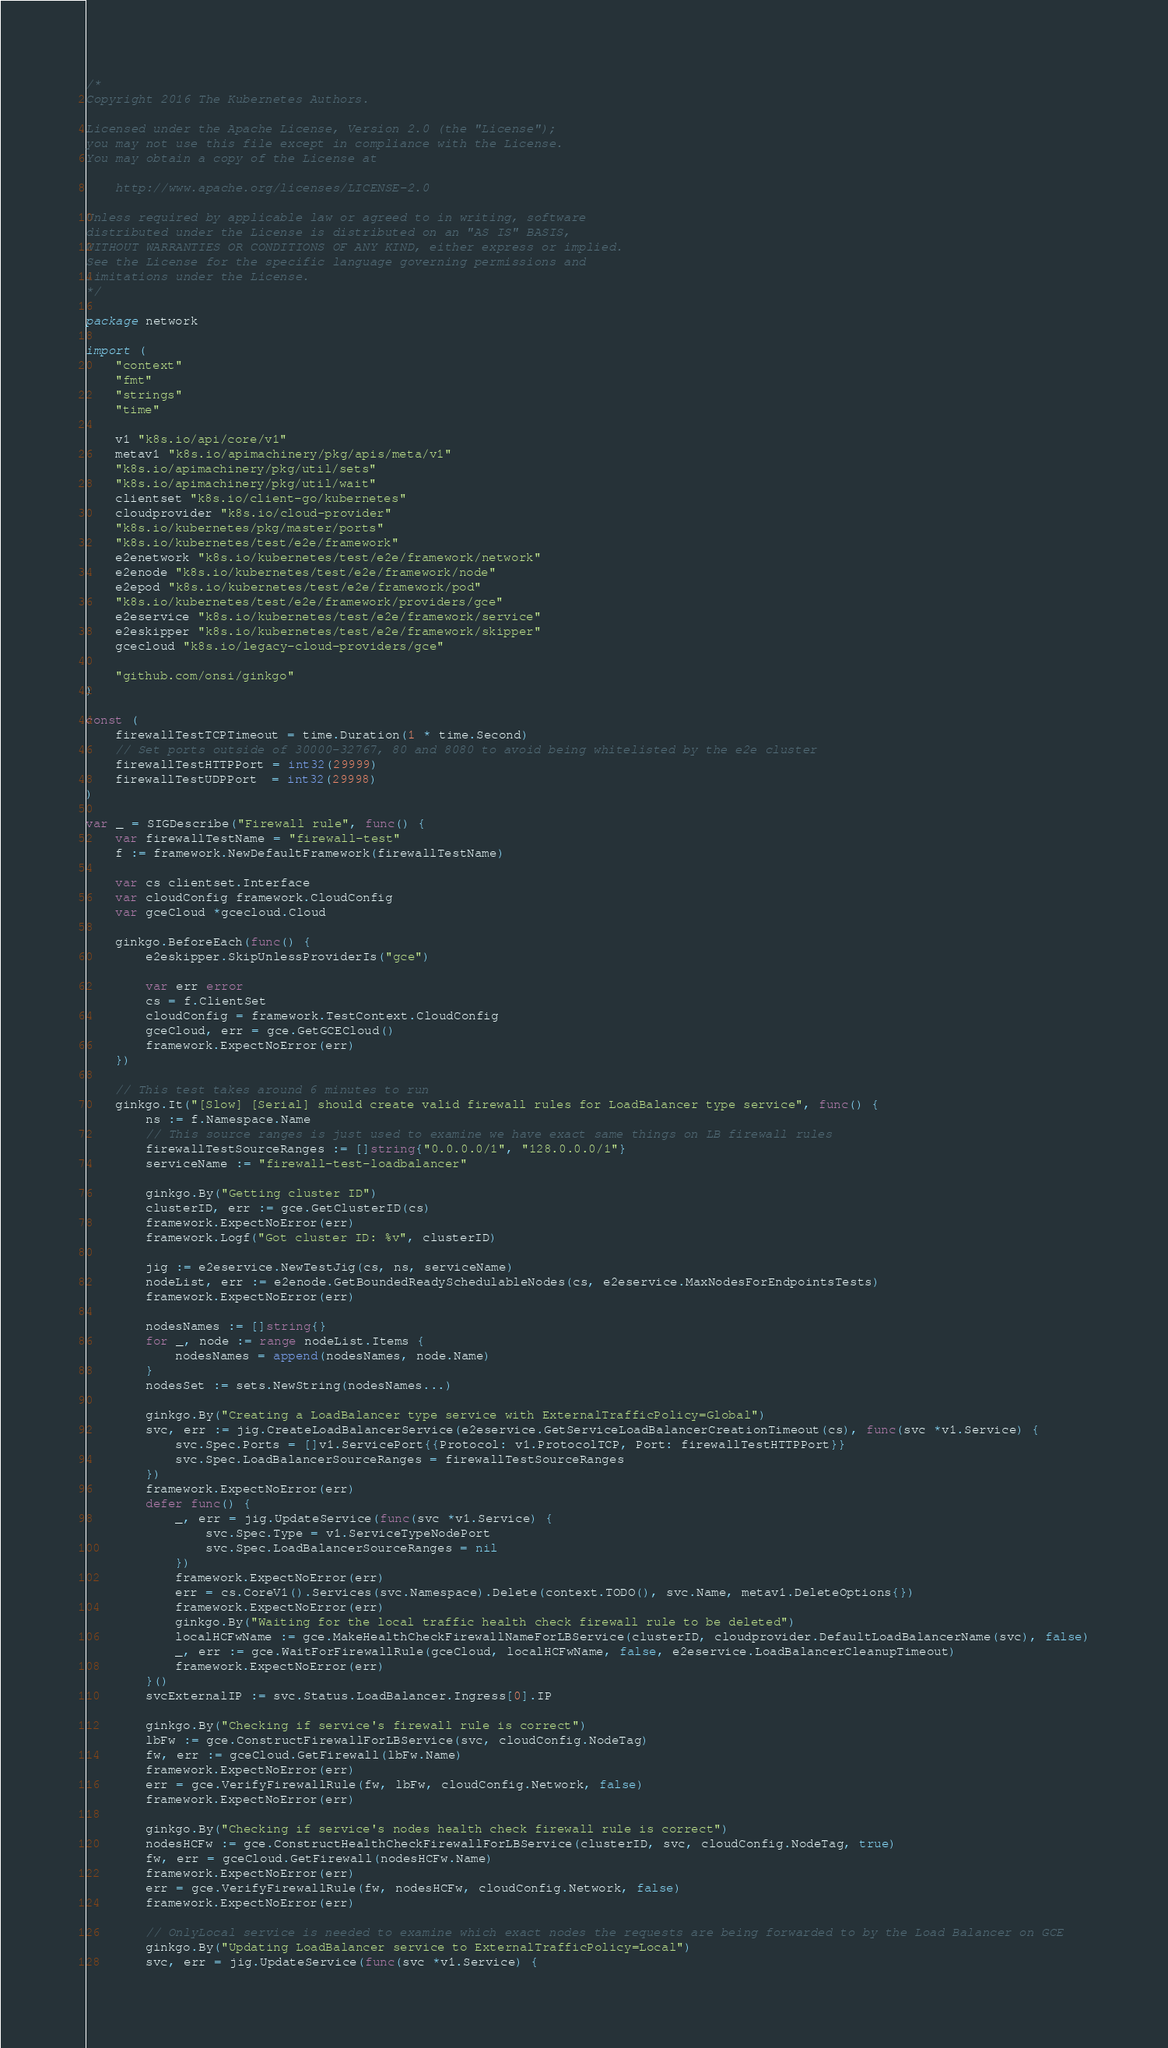Convert code to text. <code><loc_0><loc_0><loc_500><loc_500><_Go_>/*
Copyright 2016 The Kubernetes Authors.

Licensed under the Apache License, Version 2.0 (the "License");
you may not use this file except in compliance with the License.
You may obtain a copy of the License at

    http://www.apache.org/licenses/LICENSE-2.0

Unless required by applicable law or agreed to in writing, software
distributed under the License is distributed on an "AS IS" BASIS,
WITHOUT WARRANTIES OR CONDITIONS OF ANY KIND, either express or implied.
See the License for the specific language governing permissions and
limitations under the License.
*/

package network

import (
	"context"
	"fmt"
	"strings"
	"time"

	v1 "k8s.io/api/core/v1"
	metav1 "k8s.io/apimachinery/pkg/apis/meta/v1"
	"k8s.io/apimachinery/pkg/util/sets"
	"k8s.io/apimachinery/pkg/util/wait"
	clientset "k8s.io/client-go/kubernetes"
	cloudprovider "k8s.io/cloud-provider"
	"k8s.io/kubernetes/pkg/master/ports"
	"k8s.io/kubernetes/test/e2e/framework"
	e2enetwork "k8s.io/kubernetes/test/e2e/framework/network"
	e2enode "k8s.io/kubernetes/test/e2e/framework/node"
	e2epod "k8s.io/kubernetes/test/e2e/framework/pod"
	"k8s.io/kubernetes/test/e2e/framework/providers/gce"
	e2eservice "k8s.io/kubernetes/test/e2e/framework/service"
	e2eskipper "k8s.io/kubernetes/test/e2e/framework/skipper"
	gcecloud "k8s.io/legacy-cloud-providers/gce"

	"github.com/onsi/ginkgo"
)

const (
	firewallTestTCPTimeout = time.Duration(1 * time.Second)
	// Set ports outside of 30000-32767, 80 and 8080 to avoid being whitelisted by the e2e cluster
	firewallTestHTTPPort = int32(29999)
	firewallTestUDPPort  = int32(29998)
)

var _ = SIGDescribe("Firewall rule", func() {
	var firewallTestName = "firewall-test"
	f := framework.NewDefaultFramework(firewallTestName)

	var cs clientset.Interface
	var cloudConfig framework.CloudConfig
	var gceCloud *gcecloud.Cloud

	ginkgo.BeforeEach(func() {
		e2eskipper.SkipUnlessProviderIs("gce")

		var err error
		cs = f.ClientSet
		cloudConfig = framework.TestContext.CloudConfig
		gceCloud, err = gce.GetGCECloud()
		framework.ExpectNoError(err)
	})

	// This test takes around 6 minutes to run
	ginkgo.It("[Slow] [Serial] should create valid firewall rules for LoadBalancer type service", func() {
		ns := f.Namespace.Name
		// This source ranges is just used to examine we have exact same things on LB firewall rules
		firewallTestSourceRanges := []string{"0.0.0.0/1", "128.0.0.0/1"}
		serviceName := "firewall-test-loadbalancer"

		ginkgo.By("Getting cluster ID")
		clusterID, err := gce.GetClusterID(cs)
		framework.ExpectNoError(err)
		framework.Logf("Got cluster ID: %v", clusterID)

		jig := e2eservice.NewTestJig(cs, ns, serviceName)
		nodeList, err := e2enode.GetBoundedReadySchedulableNodes(cs, e2eservice.MaxNodesForEndpointsTests)
		framework.ExpectNoError(err)

		nodesNames := []string{}
		for _, node := range nodeList.Items {
			nodesNames = append(nodesNames, node.Name)
		}
		nodesSet := sets.NewString(nodesNames...)

		ginkgo.By("Creating a LoadBalancer type service with ExternalTrafficPolicy=Global")
		svc, err := jig.CreateLoadBalancerService(e2eservice.GetServiceLoadBalancerCreationTimeout(cs), func(svc *v1.Service) {
			svc.Spec.Ports = []v1.ServicePort{{Protocol: v1.ProtocolTCP, Port: firewallTestHTTPPort}}
			svc.Spec.LoadBalancerSourceRanges = firewallTestSourceRanges
		})
		framework.ExpectNoError(err)
		defer func() {
			_, err = jig.UpdateService(func(svc *v1.Service) {
				svc.Spec.Type = v1.ServiceTypeNodePort
				svc.Spec.LoadBalancerSourceRanges = nil
			})
			framework.ExpectNoError(err)
			err = cs.CoreV1().Services(svc.Namespace).Delete(context.TODO(), svc.Name, metav1.DeleteOptions{})
			framework.ExpectNoError(err)
			ginkgo.By("Waiting for the local traffic health check firewall rule to be deleted")
			localHCFwName := gce.MakeHealthCheckFirewallNameForLBService(clusterID, cloudprovider.DefaultLoadBalancerName(svc), false)
			_, err := gce.WaitForFirewallRule(gceCloud, localHCFwName, false, e2eservice.LoadBalancerCleanupTimeout)
			framework.ExpectNoError(err)
		}()
		svcExternalIP := svc.Status.LoadBalancer.Ingress[0].IP

		ginkgo.By("Checking if service's firewall rule is correct")
		lbFw := gce.ConstructFirewallForLBService(svc, cloudConfig.NodeTag)
		fw, err := gceCloud.GetFirewall(lbFw.Name)
		framework.ExpectNoError(err)
		err = gce.VerifyFirewallRule(fw, lbFw, cloudConfig.Network, false)
		framework.ExpectNoError(err)

		ginkgo.By("Checking if service's nodes health check firewall rule is correct")
		nodesHCFw := gce.ConstructHealthCheckFirewallForLBService(clusterID, svc, cloudConfig.NodeTag, true)
		fw, err = gceCloud.GetFirewall(nodesHCFw.Name)
		framework.ExpectNoError(err)
		err = gce.VerifyFirewallRule(fw, nodesHCFw, cloudConfig.Network, false)
		framework.ExpectNoError(err)

		// OnlyLocal service is needed to examine which exact nodes the requests are being forwarded to by the Load Balancer on GCE
		ginkgo.By("Updating LoadBalancer service to ExternalTrafficPolicy=Local")
		svc, err = jig.UpdateService(func(svc *v1.Service) {</code> 